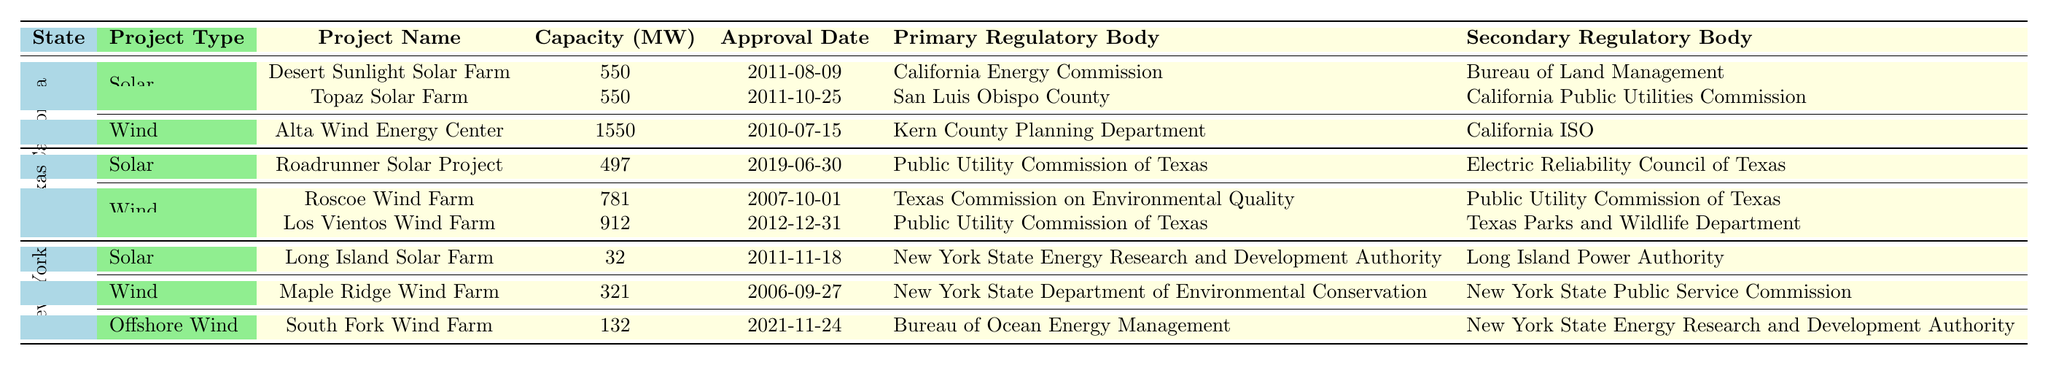What is the capacity of the Desert Sunlight Solar Farm? The table lists the project name "Desert Sunlight Solar Farm" under California's solar projects, and it shows a capacity of 550 MW.
Answer: 550 MW How many months did it take to approve the Long Island Solar Farm? The approval timeline for "Long Island Solar Farm" is listed as 14 months in the New York section of solar projects.
Answer: 14 months Which state has the highest capacity in wind projects? The table indicates that California has a wind project, "Alta Wind Energy Center," with a capacity of 1550 MW, which is higher than Texas's highest wind project at 912 MW.
Answer: California What is the total capacity of solar projects in Texas? Texas has one solar project listed, the "Roadrunner Solar Project," with a capacity of 497 MW. Since there is only one project, the total capacity is simply 497 MW.
Answer: 497 MW Which regulatory body is involved in the approval of the South Fork Wind Farm? The "South Fork Wind Farm" is associated with the "Bureau of Ocean Energy Management" as its primary regulatory body, as noted in the table under New York's offshore wind projects.
Answer: Bureau of Ocean Energy Management What is the difference in approval timeline between the Roscoe Wind Farm and the Los Vientos Wind Farm? The Roscoe Wind Farm has an approval timeline of 15 months, while the Los Vientos Wind Farm's timeline is 22 months. The difference is 22 - 15 = 7 months.
Answer: 7 months Does Texas have more solar projects than New York? The table shows that Texas has 1 solar project while New York also has 1 solar project. Therefore, Texas does not have more solar projects than New York; they have an equal number.
Answer: No What is the average capacity of the solar projects listed in California? California's solar projects include "Desert Sunlight Solar Farm" with 550 MW and "Topaz Solar Farm" with 550 MW. The average capacity is (550 + 550) / 2 = 550 MW.
Answer: 550 MW How many regulatory bodies are involved in the approval process for wind projects in Texas? The Roscoe Wind Farm involves the Texas Commission on Environmental Quality and the Public Utility Commission of Texas as regulatory bodies, and the Los Vientos Wind Farm involves the Public Utility Commission of Texas and Texas Parks and Wildlife Department. This totals 4 distinct regulatory bodies.
Answer: 4 Which project had the longest approval timeline and what is its duration? In the table, “South Fork Wind Farm” has the longest approval timeline of 48 months among all projects listed.
Answer: 48 months 